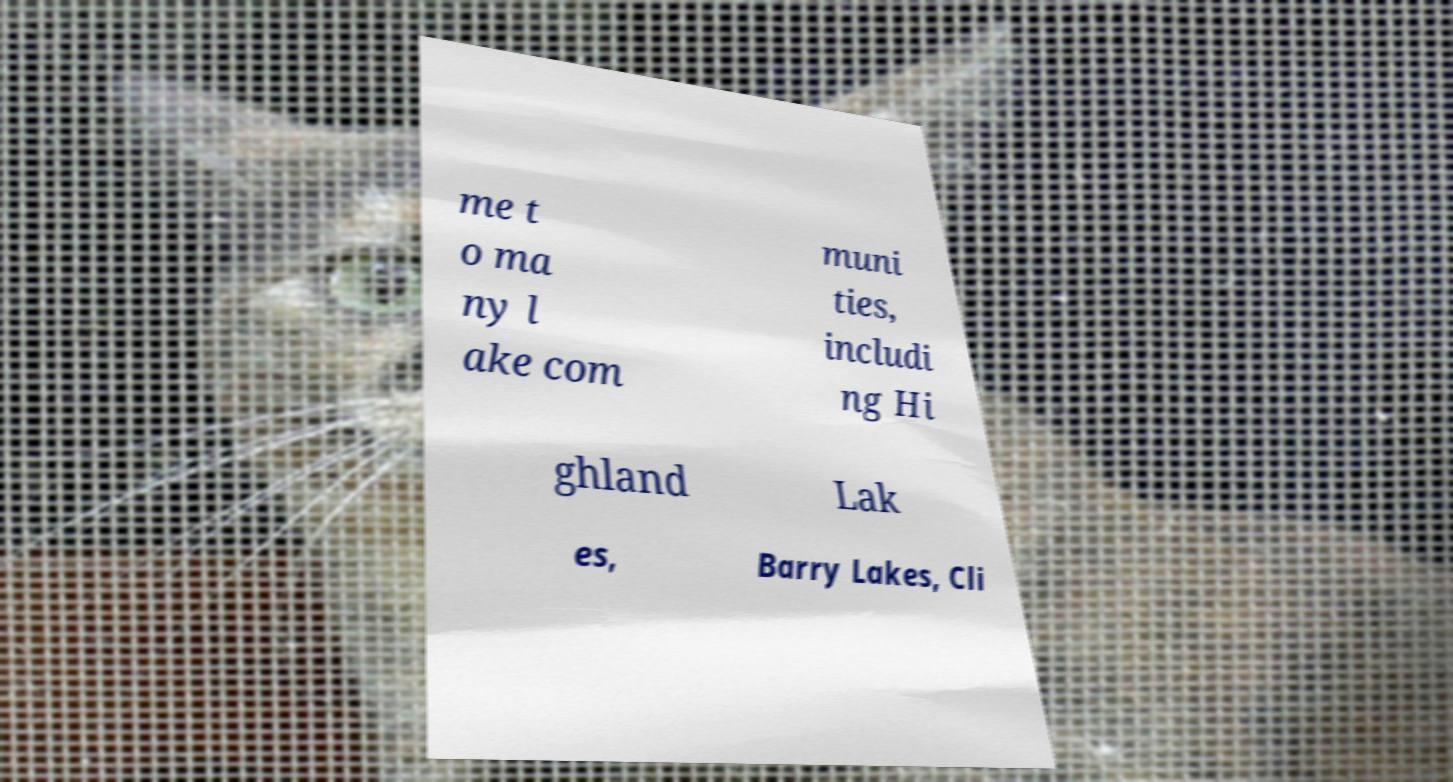I need the written content from this picture converted into text. Can you do that? me t o ma ny l ake com muni ties, includi ng Hi ghland Lak es, Barry Lakes, Cli 